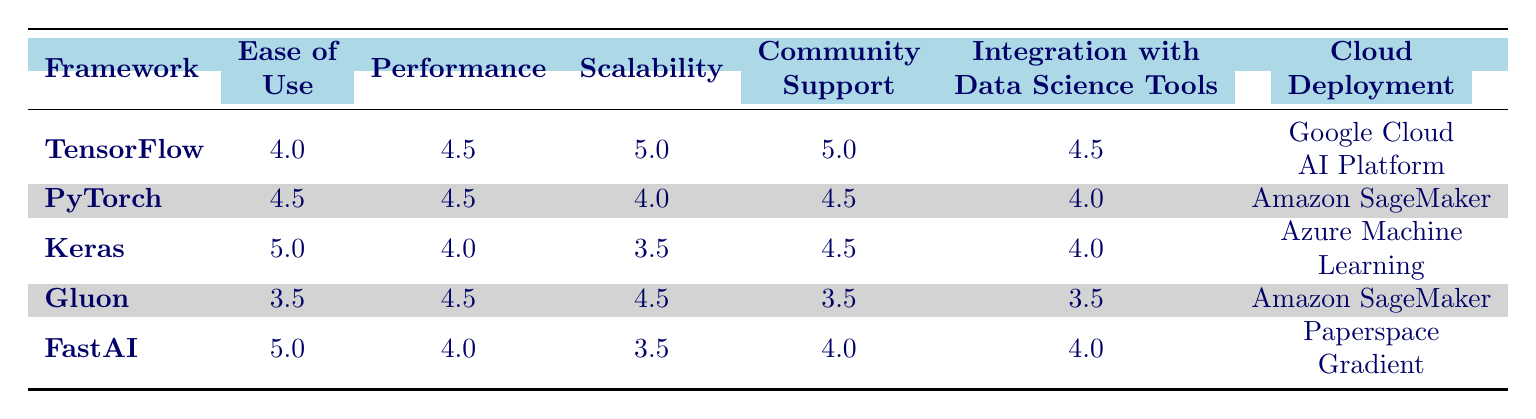What framework has the highest ease of use score? The ease of use scores are as follows: TensorFlow (4.0), PyTorch (4.5), Keras (5.0), Gluon (3.5), and FastAI (5.0). Keras and FastAI both have the highest score of 5.0.
Answer: Keras and FastAI Which framework has the best scalability rating? The scalability ratings are: TensorFlow (5.0), PyTorch (4.0), Keras (3.5), Gluon (4.5), and FastAI (3.5). TensorFlow has the highest scalability score at 5.0.
Answer: TensorFlow Is PyTorch more scalable than Keras? The scalability ratings are: PyTorch (4.0) and Keras (3.5). Since 4.0 is greater than 3.5, PyTorch is indeed more scalable than Keras.
Answer: Yes What is the average performance score of the frameworks? The performance scores are: TensorFlow (4.5), PyTorch (4.5), Keras (4.0), Gluon (4.5), and FastAI (4.0). Their sum is 4.5 + 4.5 + 4.0 + 4.5 + 4.0 = 21.5. Dividing by 5 yields the average score of 4.3.
Answer: 4.3 Which cloud deployment option is used by TensorFlow? The cloud deployment for TensorFlow listed in the table is Google Cloud AI Platform.
Answer: Google Cloud AI Platform Which framework has the lowest community support rating? Based on the community support ratings: TensorFlow (5.0), PyTorch (4.5), Keras (4.5), Gluon (3.5), and FastAI (4.0). Gluon has the lowest rating at 3.5.
Answer: Gluon What is the minimum RAM requirement for FastAI? The minimum RAM requirement for FastAI, as per the data, is 16GB.
Answer: 16GB Is there a framework that has a recommended GPU of NVIDIA GeForce GTX 1080 Ti? Keras has a recommended GPU of NVIDIA GeForce GTX 1080 Ti.
Answer: Yes 